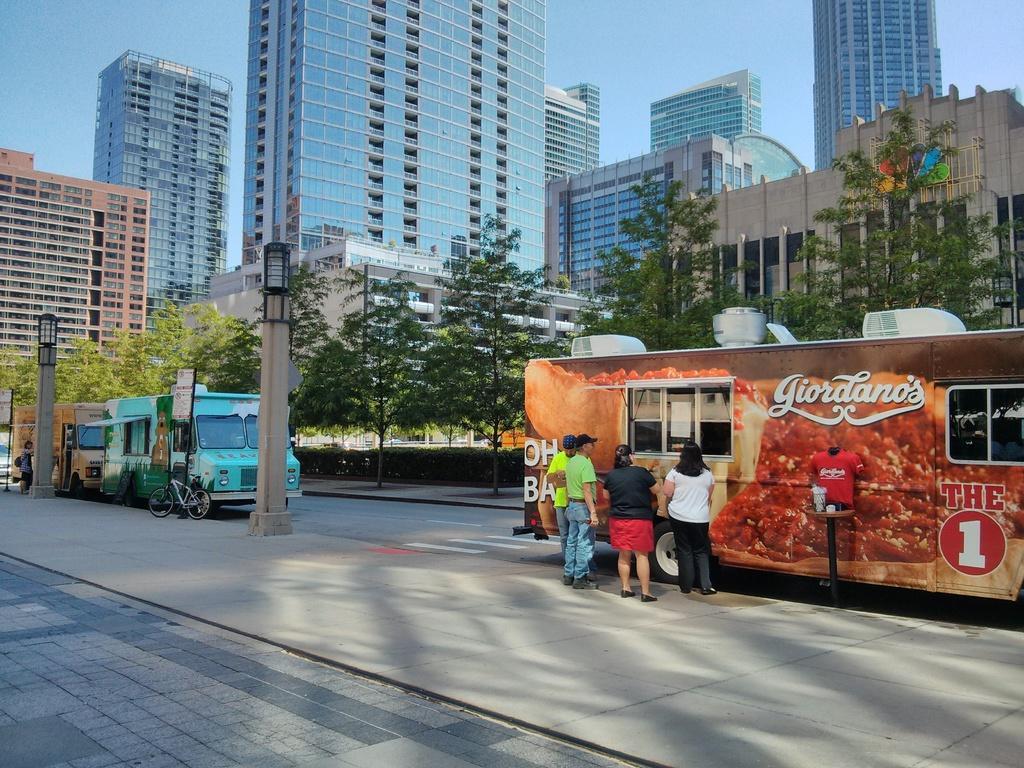Describe this image in one or two sentences. In this image there are vehicles on the road beside that there are people standing, on the other side there are buildings and trees. 